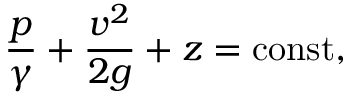Convert formula to latex. <formula><loc_0><loc_0><loc_500><loc_500>{ \frac { p } { \gamma } } + { \frac { v ^ { 2 } } { 2 g } } + z = c o n s t ,</formula> 